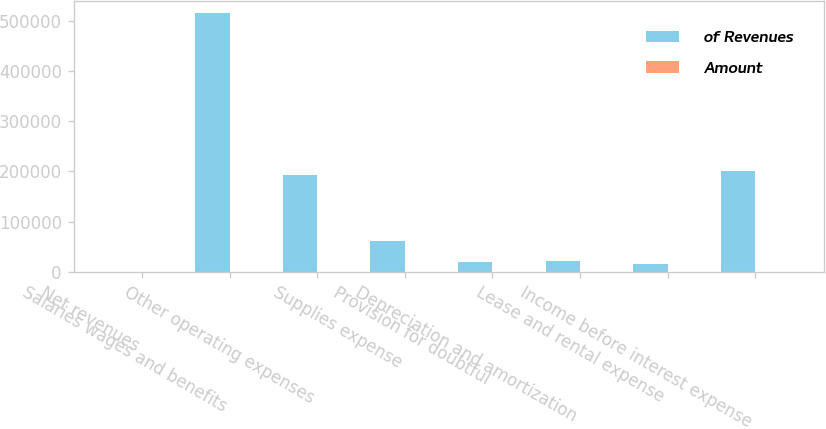Convert chart to OTSL. <chart><loc_0><loc_0><loc_500><loc_500><stacked_bar_chart><ecel><fcel>Net revenues<fcel>Salaries wages and benefits<fcel>Other operating expenses<fcel>Supplies expense<fcel>Provision for doubtful<fcel>Depreciation and amortization<fcel>Lease and rental expense<fcel>Income before interest expense<nl><fcel>of Revenues<fcel>100<fcel>513979<fcel>193397<fcel>61027<fcel>20507<fcel>22154<fcel>16240<fcel>201663<nl><fcel>Amount<fcel>100<fcel>49.9<fcel>18.8<fcel>5.9<fcel>2<fcel>2.2<fcel>1.6<fcel>19.6<nl></chart> 